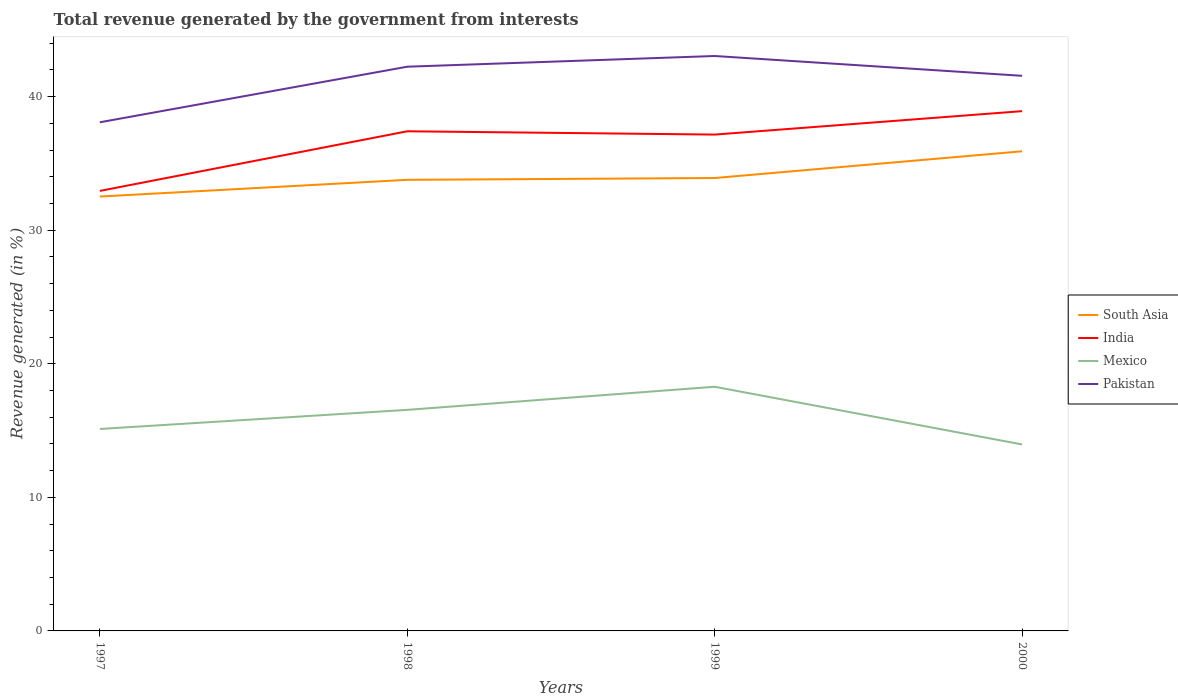How many different coloured lines are there?
Your answer should be very brief. 4. Across all years, what is the maximum total revenue generated in India?
Keep it short and to the point. 32.94. What is the total total revenue generated in Mexico in the graph?
Your response must be concise. -1.43. What is the difference between the highest and the second highest total revenue generated in Mexico?
Give a very brief answer. 4.32. What is the difference between the highest and the lowest total revenue generated in Pakistan?
Give a very brief answer. 3. How many years are there in the graph?
Your answer should be compact. 4. Are the values on the major ticks of Y-axis written in scientific E-notation?
Ensure brevity in your answer.  No. Does the graph contain any zero values?
Provide a succinct answer. No. Does the graph contain grids?
Offer a very short reply. No. How many legend labels are there?
Your answer should be compact. 4. How are the legend labels stacked?
Offer a terse response. Vertical. What is the title of the graph?
Offer a terse response. Total revenue generated by the government from interests. What is the label or title of the Y-axis?
Provide a short and direct response. Revenue generated (in %). What is the Revenue generated (in %) in South Asia in 1997?
Give a very brief answer. 32.52. What is the Revenue generated (in %) in India in 1997?
Offer a terse response. 32.94. What is the Revenue generated (in %) of Mexico in 1997?
Offer a terse response. 15.12. What is the Revenue generated (in %) in Pakistan in 1997?
Your answer should be compact. 38.08. What is the Revenue generated (in %) in South Asia in 1998?
Your answer should be compact. 33.77. What is the Revenue generated (in %) of India in 1998?
Provide a succinct answer. 37.41. What is the Revenue generated (in %) in Mexico in 1998?
Offer a terse response. 16.55. What is the Revenue generated (in %) of Pakistan in 1998?
Provide a succinct answer. 42.24. What is the Revenue generated (in %) of South Asia in 1999?
Give a very brief answer. 33.91. What is the Revenue generated (in %) of India in 1999?
Ensure brevity in your answer.  37.16. What is the Revenue generated (in %) of Mexico in 1999?
Offer a terse response. 18.28. What is the Revenue generated (in %) of Pakistan in 1999?
Keep it short and to the point. 43.04. What is the Revenue generated (in %) in South Asia in 2000?
Offer a very short reply. 35.91. What is the Revenue generated (in %) in India in 2000?
Keep it short and to the point. 38.91. What is the Revenue generated (in %) in Mexico in 2000?
Your response must be concise. 13.96. What is the Revenue generated (in %) in Pakistan in 2000?
Offer a terse response. 41.56. Across all years, what is the maximum Revenue generated (in %) in South Asia?
Provide a short and direct response. 35.91. Across all years, what is the maximum Revenue generated (in %) in India?
Your answer should be compact. 38.91. Across all years, what is the maximum Revenue generated (in %) in Mexico?
Provide a short and direct response. 18.28. Across all years, what is the maximum Revenue generated (in %) of Pakistan?
Offer a very short reply. 43.04. Across all years, what is the minimum Revenue generated (in %) in South Asia?
Give a very brief answer. 32.52. Across all years, what is the minimum Revenue generated (in %) of India?
Give a very brief answer. 32.94. Across all years, what is the minimum Revenue generated (in %) of Mexico?
Your answer should be compact. 13.96. Across all years, what is the minimum Revenue generated (in %) of Pakistan?
Give a very brief answer. 38.08. What is the total Revenue generated (in %) in South Asia in the graph?
Your response must be concise. 136.11. What is the total Revenue generated (in %) in India in the graph?
Provide a succinct answer. 146.42. What is the total Revenue generated (in %) of Mexico in the graph?
Offer a very short reply. 63.91. What is the total Revenue generated (in %) in Pakistan in the graph?
Offer a terse response. 164.92. What is the difference between the Revenue generated (in %) in South Asia in 1997 and that in 1998?
Your answer should be very brief. -1.25. What is the difference between the Revenue generated (in %) of India in 1997 and that in 1998?
Your response must be concise. -4.46. What is the difference between the Revenue generated (in %) of Mexico in 1997 and that in 1998?
Provide a succinct answer. -1.43. What is the difference between the Revenue generated (in %) of Pakistan in 1997 and that in 1998?
Ensure brevity in your answer.  -4.16. What is the difference between the Revenue generated (in %) in South Asia in 1997 and that in 1999?
Make the answer very short. -1.39. What is the difference between the Revenue generated (in %) of India in 1997 and that in 1999?
Your answer should be compact. -4.22. What is the difference between the Revenue generated (in %) of Mexico in 1997 and that in 1999?
Give a very brief answer. -3.16. What is the difference between the Revenue generated (in %) in Pakistan in 1997 and that in 1999?
Make the answer very short. -4.96. What is the difference between the Revenue generated (in %) in South Asia in 1997 and that in 2000?
Give a very brief answer. -3.39. What is the difference between the Revenue generated (in %) of India in 1997 and that in 2000?
Offer a terse response. -5.97. What is the difference between the Revenue generated (in %) in Mexico in 1997 and that in 2000?
Make the answer very short. 1.16. What is the difference between the Revenue generated (in %) of Pakistan in 1997 and that in 2000?
Keep it short and to the point. -3.48. What is the difference between the Revenue generated (in %) of South Asia in 1998 and that in 1999?
Offer a very short reply. -0.14. What is the difference between the Revenue generated (in %) in India in 1998 and that in 1999?
Your answer should be compact. 0.25. What is the difference between the Revenue generated (in %) of Mexico in 1998 and that in 1999?
Keep it short and to the point. -1.73. What is the difference between the Revenue generated (in %) in Pakistan in 1998 and that in 1999?
Your answer should be very brief. -0.8. What is the difference between the Revenue generated (in %) of South Asia in 1998 and that in 2000?
Your answer should be compact. -2.14. What is the difference between the Revenue generated (in %) in India in 1998 and that in 2000?
Make the answer very short. -1.51. What is the difference between the Revenue generated (in %) of Mexico in 1998 and that in 2000?
Make the answer very short. 2.59. What is the difference between the Revenue generated (in %) in Pakistan in 1998 and that in 2000?
Give a very brief answer. 0.68. What is the difference between the Revenue generated (in %) of South Asia in 1999 and that in 2000?
Your answer should be very brief. -2. What is the difference between the Revenue generated (in %) in India in 1999 and that in 2000?
Your response must be concise. -1.75. What is the difference between the Revenue generated (in %) in Mexico in 1999 and that in 2000?
Ensure brevity in your answer.  4.32. What is the difference between the Revenue generated (in %) in Pakistan in 1999 and that in 2000?
Your answer should be compact. 1.48. What is the difference between the Revenue generated (in %) in South Asia in 1997 and the Revenue generated (in %) in India in 1998?
Your answer should be compact. -4.88. What is the difference between the Revenue generated (in %) in South Asia in 1997 and the Revenue generated (in %) in Mexico in 1998?
Ensure brevity in your answer.  15.97. What is the difference between the Revenue generated (in %) in South Asia in 1997 and the Revenue generated (in %) in Pakistan in 1998?
Your answer should be very brief. -9.72. What is the difference between the Revenue generated (in %) in India in 1997 and the Revenue generated (in %) in Mexico in 1998?
Keep it short and to the point. 16.39. What is the difference between the Revenue generated (in %) in India in 1997 and the Revenue generated (in %) in Pakistan in 1998?
Ensure brevity in your answer.  -9.3. What is the difference between the Revenue generated (in %) of Mexico in 1997 and the Revenue generated (in %) of Pakistan in 1998?
Ensure brevity in your answer.  -27.12. What is the difference between the Revenue generated (in %) of South Asia in 1997 and the Revenue generated (in %) of India in 1999?
Make the answer very short. -4.64. What is the difference between the Revenue generated (in %) of South Asia in 1997 and the Revenue generated (in %) of Mexico in 1999?
Provide a succinct answer. 14.24. What is the difference between the Revenue generated (in %) of South Asia in 1997 and the Revenue generated (in %) of Pakistan in 1999?
Your response must be concise. -10.52. What is the difference between the Revenue generated (in %) in India in 1997 and the Revenue generated (in %) in Mexico in 1999?
Your answer should be compact. 14.66. What is the difference between the Revenue generated (in %) of India in 1997 and the Revenue generated (in %) of Pakistan in 1999?
Your answer should be very brief. -10.1. What is the difference between the Revenue generated (in %) in Mexico in 1997 and the Revenue generated (in %) in Pakistan in 1999?
Keep it short and to the point. -27.92. What is the difference between the Revenue generated (in %) in South Asia in 1997 and the Revenue generated (in %) in India in 2000?
Ensure brevity in your answer.  -6.39. What is the difference between the Revenue generated (in %) in South Asia in 1997 and the Revenue generated (in %) in Mexico in 2000?
Provide a succinct answer. 18.56. What is the difference between the Revenue generated (in %) of South Asia in 1997 and the Revenue generated (in %) of Pakistan in 2000?
Offer a terse response. -9.04. What is the difference between the Revenue generated (in %) of India in 1997 and the Revenue generated (in %) of Mexico in 2000?
Give a very brief answer. 18.98. What is the difference between the Revenue generated (in %) in India in 1997 and the Revenue generated (in %) in Pakistan in 2000?
Keep it short and to the point. -8.62. What is the difference between the Revenue generated (in %) of Mexico in 1997 and the Revenue generated (in %) of Pakistan in 2000?
Provide a short and direct response. -26.44. What is the difference between the Revenue generated (in %) of South Asia in 1998 and the Revenue generated (in %) of India in 1999?
Offer a terse response. -3.39. What is the difference between the Revenue generated (in %) in South Asia in 1998 and the Revenue generated (in %) in Mexico in 1999?
Keep it short and to the point. 15.49. What is the difference between the Revenue generated (in %) of South Asia in 1998 and the Revenue generated (in %) of Pakistan in 1999?
Make the answer very short. -9.27. What is the difference between the Revenue generated (in %) in India in 1998 and the Revenue generated (in %) in Mexico in 1999?
Make the answer very short. 19.13. What is the difference between the Revenue generated (in %) in India in 1998 and the Revenue generated (in %) in Pakistan in 1999?
Give a very brief answer. -5.64. What is the difference between the Revenue generated (in %) in Mexico in 1998 and the Revenue generated (in %) in Pakistan in 1999?
Your answer should be very brief. -26.49. What is the difference between the Revenue generated (in %) of South Asia in 1998 and the Revenue generated (in %) of India in 2000?
Offer a terse response. -5.14. What is the difference between the Revenue generated (in %) in South Asia in 1998 and the Revenue generated (in %) in Mexico in 2000?
Give a very brief answer. 19.81. What is the difference between the Revenue generated (in %) of South Asia in 1998 and the Revenue generated (in %) of Pakistan in 2000?
Make the answer very short. -7.79. What is the difference between the Revenue generated (in %) of India in 1998 and the Revenue generated (in %) of Mexico in 2000?
Ensure brevity in your answer.  23.45. What is the difference between the Revenue generated (in %) in India in 1998 and the Revenue generated (in %) in Pakistan in 2000?
Ensure brevity in your answer.  -4.15. What is the difference between the Revenue generated (in %) in Mexico in 1998 and the Revenue generated (in %) in Pakistan in 2000?
Your answer should be compact. -25.01. What is the difference between the Revenue generated (in %) of South Asia in 1999 and the Revenue generated (in %) of India in 2000?
Offer a very short reply. -5.01. What is the difference between the Revenue generated (in %) in South Asia in 1999 and the Revenue generated (in %) in Mexico in 2000?
Make the answer very short. 19.95. What is the difference between the Revenue generated (in %) of South Asia in 1999 and the Revenue generated (in %) of Pakistan in 2000?
Provide a short and direct response. -7.65. What is the difference between the Revenue generated (in %) in India in 1999 and the Revenue generated (in %) in Mexico in 2000?
Provide a succinct answer. 23.2. What is the difference between the Revenue generated (in %) in India in 1999 and the Revenue generated (in %) in Pakistan in 2000?
Your response must be concise. -4.4. What is the difference between the Revenue generated (in %) of Mexico in 1999 and the Revenue generated (in %) of Pakistan in 2000?
Ensure brevity in your answer.  -23.28. What is the average Revenue generated (in %) of South Asia per year?
Provide a short and direct response. 34.03. What is the average Revenue generated (in %) in India per year?
Your answer should be very brief. 36.6. What is the average Revenue generated (in %) in Mexico per year?
Ensure brevity in your answer.  15.98. What is the average Revenue generated (in %) of Pakistan per year?
Provide a short and direct response. 41.23. In the year 1997, what is the difference between the Revenue generated (in %) of South Asia and Revenue generated (in %) of India?
Keep it short and to the point. -0.42. In the year 1997, what is the difference between the Revenue generated (in %) of South Asia and Revenue generated (in %) of Mexico?
Offer a very short reply. 17.4. In the year 1997, what is the difference between the Revenue generated (in %) in South Asia and Revenue generated (in %) in Pakistan?
Make the answer very short. -5.56. In the year 1997, what is the difference between the Revenue generated (in %) in India and Revenue generated (in %) in Mexico?
Provide a succinct answer. 17.82. In the year 1997, what is the difference between the Revenue generated (in %) of India and Revenue generated (in %) of Pakistan?
Make the answer very short. -5.14. In the year 1997, what is the difference between the Revenue generated (in %) of Mexico and Revenue generated (in %) of Pakistan?
Make the answer very short. -22.96. In the year 1998, what is the difference between the Revenue generated (in %) of South Asia and Revenue generated (in %) of India?
Provide a succinct answer. -3.63. In the year 1998, what is the difference between the Revenue generated (in %) in South Asia and Revenue generated (in %) in Mexico?
Provide a succinct answer. 17.22. In the year 1998, what is the difference between the Revenue generated (in %) of South Asia and Revenue generated (in %) of Pakistan?
Ensure brevity in your answer.  -8.47. In the year 1998, what is the difference between the Revenue generated (in %) in India and Revenue generated (in %) in Mexico?
Ensure brevity in your answer.  20.86. In the year 1998, what is the difference between the Revenue generated (in %) in India and Revenue generated (in %) in Pakistan?
Your answer should be compact. -4.83. In the year 1998, what is the difference between the Revenue generated (in %) of Mexico and Revenue generated (in %) of Pakistan?
Provide a succinct answer. -25.69. In the year 1999, what is the difference between the Revenue generated (in %) in South Asia and Revenue generated (in %) in India?
Your answer should be compact. -3.25. In the year 1999, what is the difference between the Revenue generated (in %) of South Asia and Revenue generated (in %) of Mexico?
Offer a very short reply. 15.63. In the year 1999, what is the difference between the Revenue generated (in %) in South Asia and Revenue generated (in %) in Pakistan?
Keep it short and to the point. -9.13. In the year 1999, what is the difference between the Revenue generated (in %) in India and Revenue generated (in %) in Mexico?
Offer a terse response. 18.88. In the year 1999, what is the difference between the Revenue generated (in %) of India and Revenue generated (in %) of Pakistan?
Offer a very short reply. -5.88. In the year 1999, what is the difference between the Revenue generated (in %) in Mexico and Revenue generated (in %) in Pakistan?
Your answer should be compact. -24.76. In the year 2000, what is the difference between the Revenue generated (in %) in South Asia and Revenue generated (in %) in India?
Keep it short and to the point. -3. In the year 2000, what is the difference between the Revenue generated (in %) in South Asia and Revenue generated (in %) in Mexico?
Provide a succinct answer. 21.95. In the year 2000, what is the difference between the Revenue generated (in %) of South Asia and Revenue generated (in %) of Pakistan?
Give a very brief answer. -5.65. In the year 2000, what is the difference between the Revenue generated (in %) of India and Revenue generated (in %) of Mexico?
Your response must be concise. 24.95. In the year 2000, what is the difference between the Revenue generated (in %) of India and Revenue generated (in %) of Pakistan?
Ensure brevity in your answer.  -2.65. In the year 2000, what is the difference between the Revenue generated (in %) of Mexico and Revenue generated (in %) of Pakistan?
Make the answer very short. -27.6. What is the ratio of the Revenue generated (in %) in India in 1997 to that in 1998?
Provide a succinct answer. 0.88. What is the ratio of the Revenue generated (in %) of Mexico in 1997 to that in 1998?
Provide a succinct answer. 0.91. What is the ratio of the Revenue generated (in %) of Pakistan in 1997 to that in 1998?
Your response must be concise. 0.9. What is the ratio of the Revenue generated (in %) in South Asia in 1997 to that in 1999?
Your answer should be compact. 0.96. What is the ratio of the Revenue generated (in %) of India in 1997 to that in 1999?
Your answer should be compact. 0.89. What is the ratio of the Revenue generated (in %) in Mexico in 1997 to that in 1999?
Offer a terse response. 0.83. What is the ratio of the Revenue generated (in %) in Pakistan in 1997 to that in 1999?
Keep it short and to the point. 0.88. What is the ratio of the Revenue generated (in %) in South Asia in 1997 to that in 2000?
Offer a terse response. 0.91. What is the ratio of the Revenue generated (in %) of India in 1997 to that in 2000?
Ensure brevity in your answer.  0.85. What is the ratio of the Revenue generated (in %) of Mexico in 1997 to that in 2000?
Provide a succinct answer. 1.08. What is the ratio of the Revenue generated (in %) of Pakistan in 1997 to that in 2000?
Offer a very short reply. 0.92. What is the ratio of the Revenue generated (in %) of India in 1998 to that in 1999?
Give a very brief answer. 1.01. What is the ratio of the Revenue generated (in %) in Mexico in 1998 to that in 1999?
Offer a very short reply. 0.91. What is the ratio of the Revenue generated (in %) of Pakistan in 1998 to that in 1999?
Your answer should be compact. 0.98. What is the ratio of the Revenue generated (in %) of South Asia in 1998 to that in 2000?
Offer a terse response. 0.94. What is the ratio of the Revenue generated (in %) in India in 1998 to that in 2000?
Ensure brevity in your answer.  0.96. What is the ratio of the Revenue generated (in %) in Mexico in 1998 to that in 2000?
Offer a very short reply. 1.19. What is the ratio of the Revenue generated (in %) of Pakistan in 1998 to that in 2000?
Make the answer very short. 1.02. What is the ratio of the Revenue generated (in %) in South Asia in 1999 to that in 2000?
Your answer should be very brief. 0.94. What is the ratio of the Revenue generated (in %) of India in 1999 to that in 2000?
Your answer should be very brief. 0.95. What is the ratio of the Revenue generated (in %) of Mexico in 1999 to that in 2000?
Ensure brevity in your answer.  1.31. What is the ratio of the Revenue generated (in %) of Pakistan in 1999 to that in 2000?
Provide a short and direct response. 1.04. What is the difference between the highest and the second highest Revenue generated (in %) of South Asia?
Give a very brief answer. 2. What is the difference between the highest and the second highest Revenue generated (in %) of India?
Your answer should be compact. 1.51. What is the difference between the highest and the second highest Revenue generated (in %) in Mexico?
Provide a succinct answer. 1.73. What is the difference between the highest and the second highest Revenue generated (in %) in Pakistan?
Provide a succinct answer. 0.8. What is the difference between the highest and the lowest Revenue generated (in %) in South Asia?
Your answer should be very brief. 3.39. What is the difference between the highest and the lowest Revenue generated (in %) of India?
Provide a succinct answer. 5.97. What is the difference between the highest and the lowest Revenue generated (in %) in Mexico?
Keep it short and to the point. 4.32. What is the difference between the highest and the lowest Revenue generated (in %) in Pakistan?
Your answer should be compact. 4.96. 